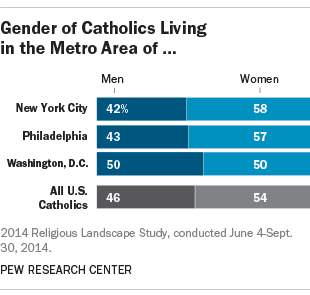Is the average percentage of men in these three cities smaller than the national average? Based on the provided image, which shows the percentage of men and women in the Catholic population within three metro areas, the average percentage of men is 45% (calculated as the mean of 42%, 43%, and 50%). This is indeed slightly lower than the national average for U.S. Catholics, which stands at 46%, as depicted in the image. Therefore, the answer is yes, the average percentage of men in these cities is smaller than the national average. 